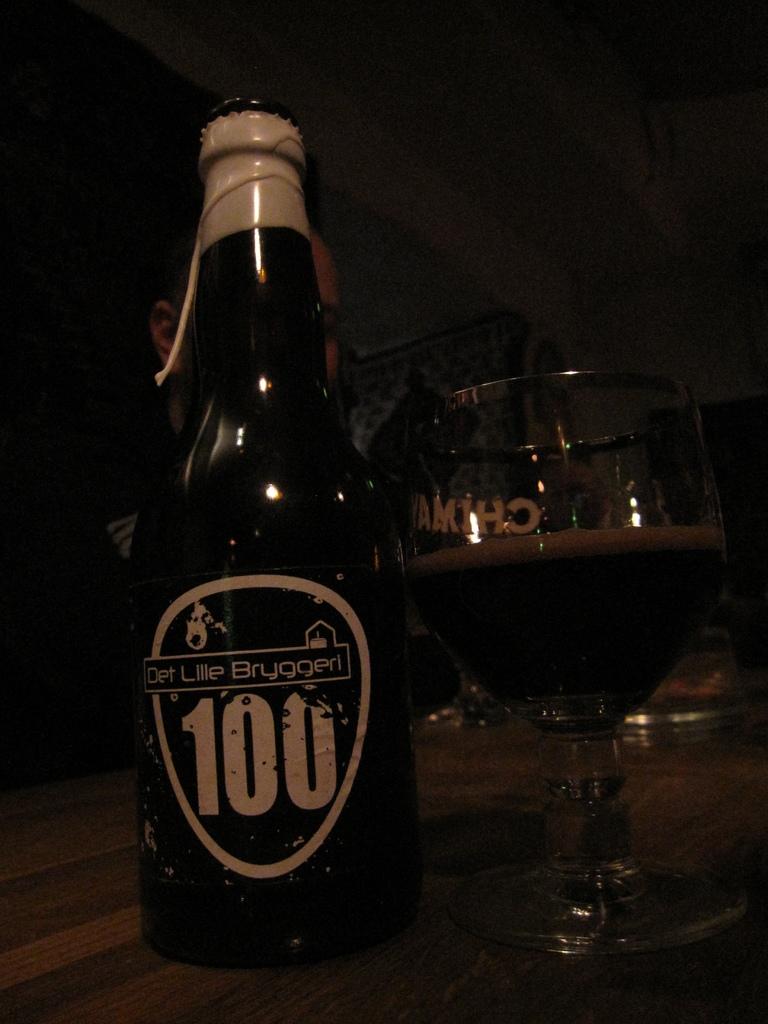What is the name on the glass?
Provide a short and direct response. 100. What number can we see on the bottle?
Make the answer very short. 100. 